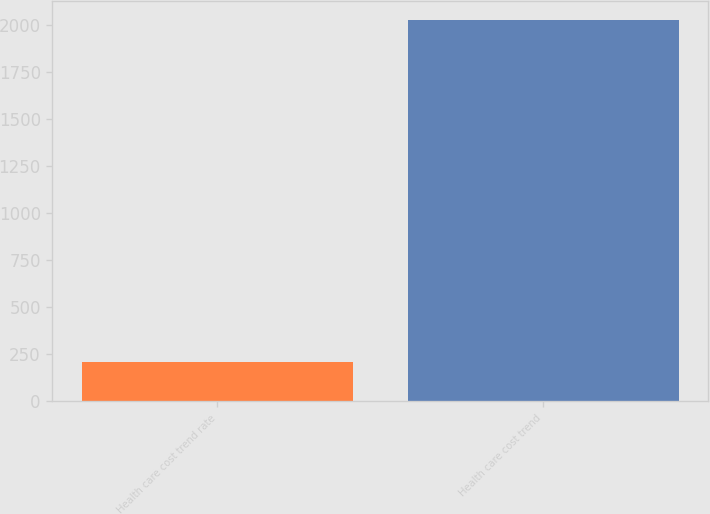Convert chart to OTSL. <chart><loc_0><loc_0><loc_500><loc_500><bar_chart><fcel>Health care cost trend rate<fcel>Health care cost trend<nl><fcel>207.1<fcel>2026<nl></chart> 